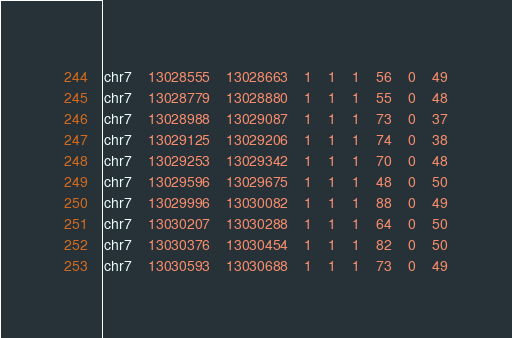Convert code to text. <code><loc_0><loc_0><loc_500><loc_500><_SQL_>chr7	13028555	13028663	1	1	1	56	0	49
chr7	13028779	13028880	1	1	1	55	0	48
chr7	13028988	13029087	1	1	1	73	0	37
chr7	13029125	13029206	1	1	1	74	0	38
chr7	13029253	13029342	1	1	1	70	0	48
chr7	13029596	13029675	1	1	1	48	0	50
chr7	13029996	13030082	1	1	1	88	0	49
chr7	13030207	13030288	1	1	1	64	0	50
chr7	13030376	13030454	1	1	1	82	0	50
chr7	13030593	13030688	1	1	1	73	0	49</code> 